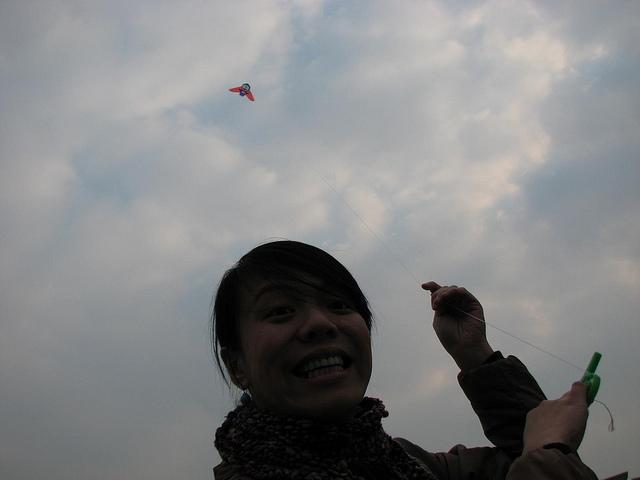How many people are there?
Give a very brief answer. 1. 